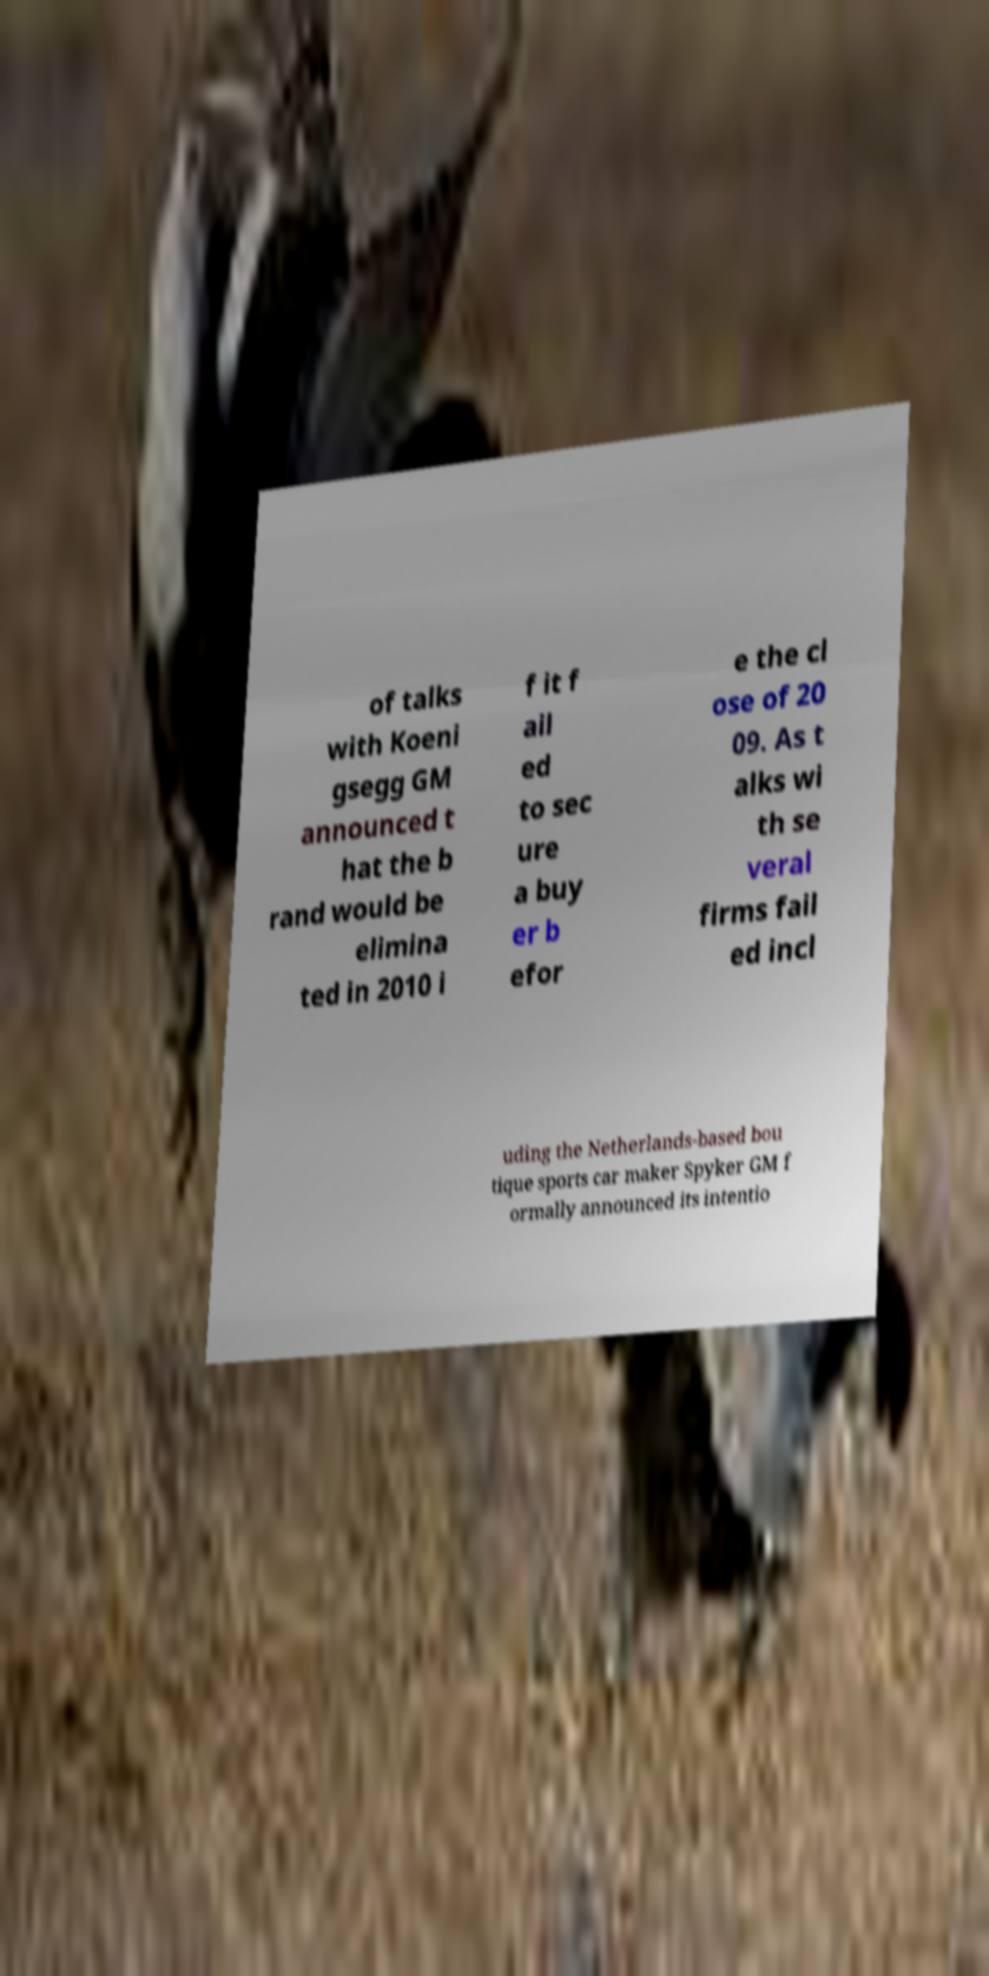Can you accurately transcribe the text from the provided image for me? of talks with Koeni gsegg GM announced t hat the b rand would be elimina ted in 2010 i f it f ail ed to sec ure a buy er b efor e the cl ose of 20 09. As t alks wi th se veral firms fail ed incl uding the Netherlands-based bou tique sports car maker Spyker GM f ormally announced its intentio 